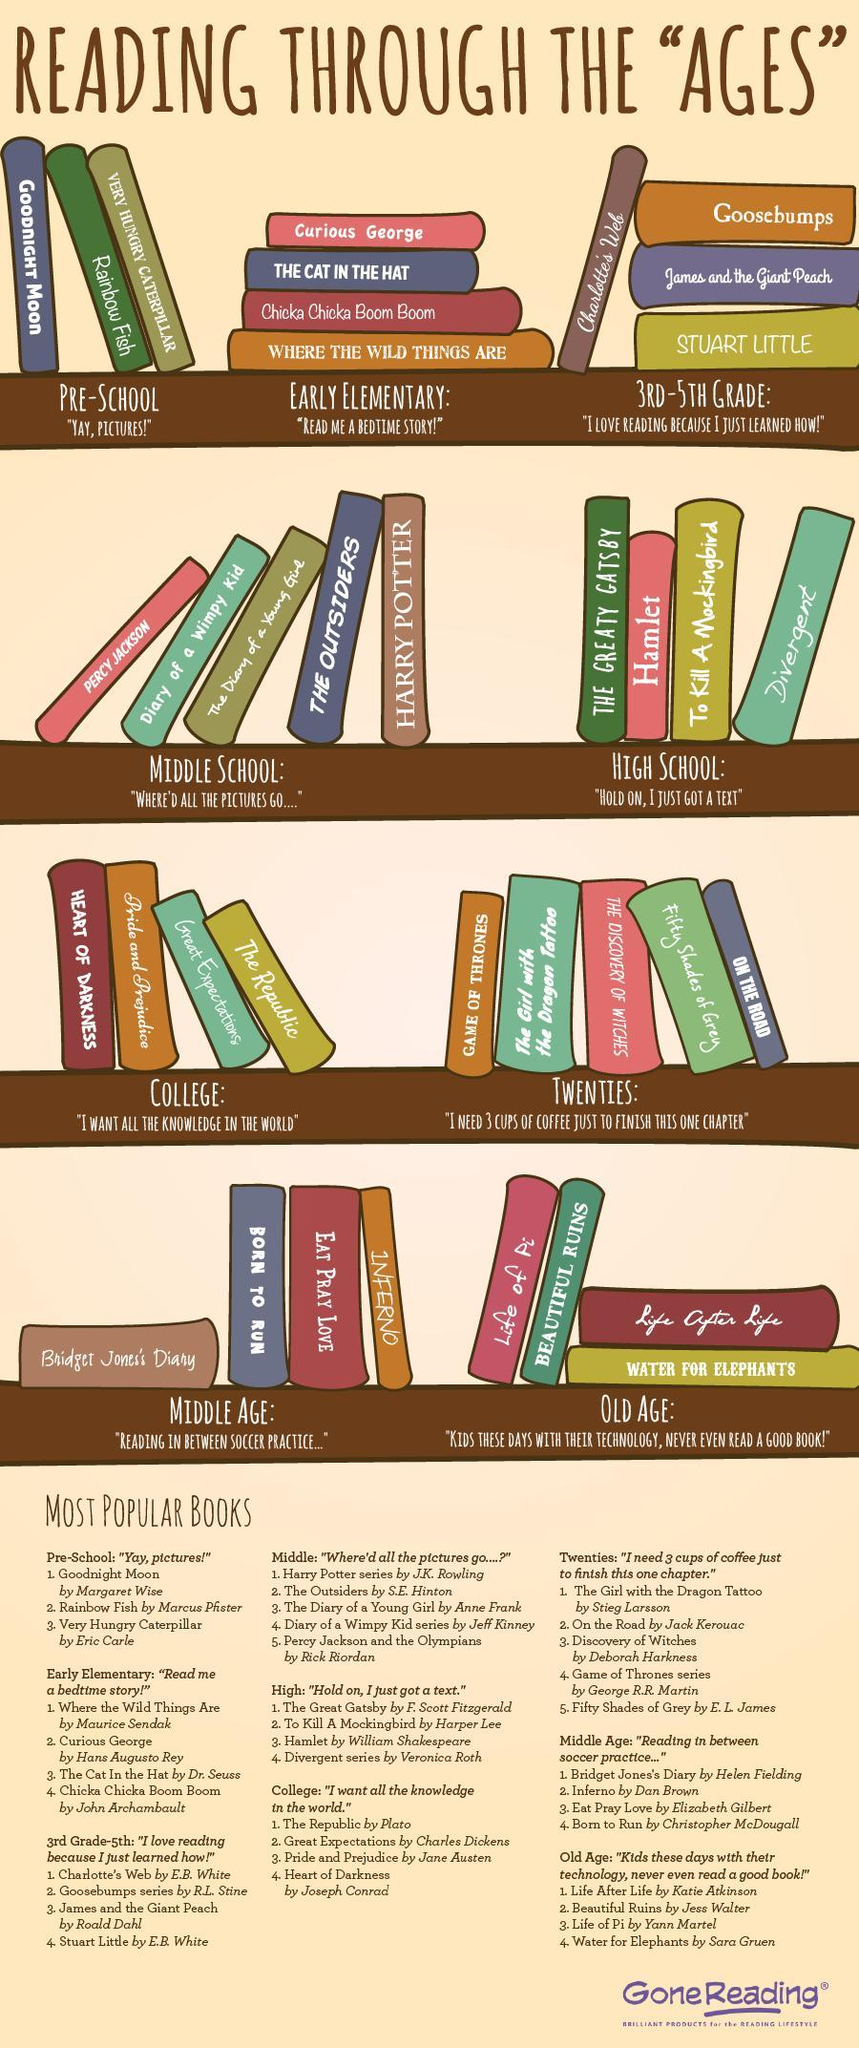What is the colour of the book Rainbow fish, green or white
Answer the question with a short phrase. green harry potter is for which group of children middle school For which age group is Eat Pray Love recommended Middle Age hamlet is for which group of readers high school Goodnight Moon is for which group of children pre-school stuart little is for which group of children 3rd-5th grade For which age group is Water for Elephants recommended Old Age Game of Thrones is recommended for which age group Twenties 